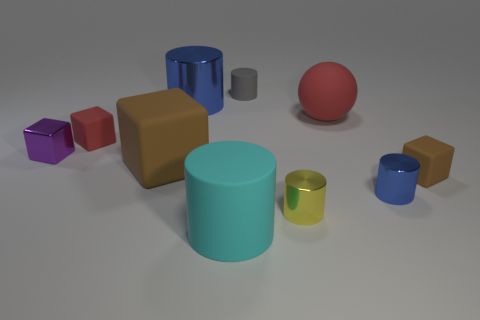Which object stands out most to you and why? The red sphere stands out most due to its vibrant color and because it's the only spherical object amidst a variety of cubes and cylinders. How does the positioning of the objects contribute to the composition of this image? The scattered arrangement of the objects with contrasting shapes and colors creates a balanced and harmonious composition that draws the eye across the entire scene. 